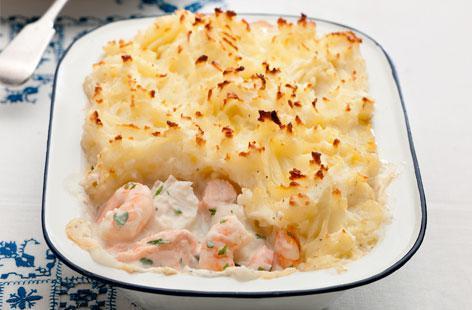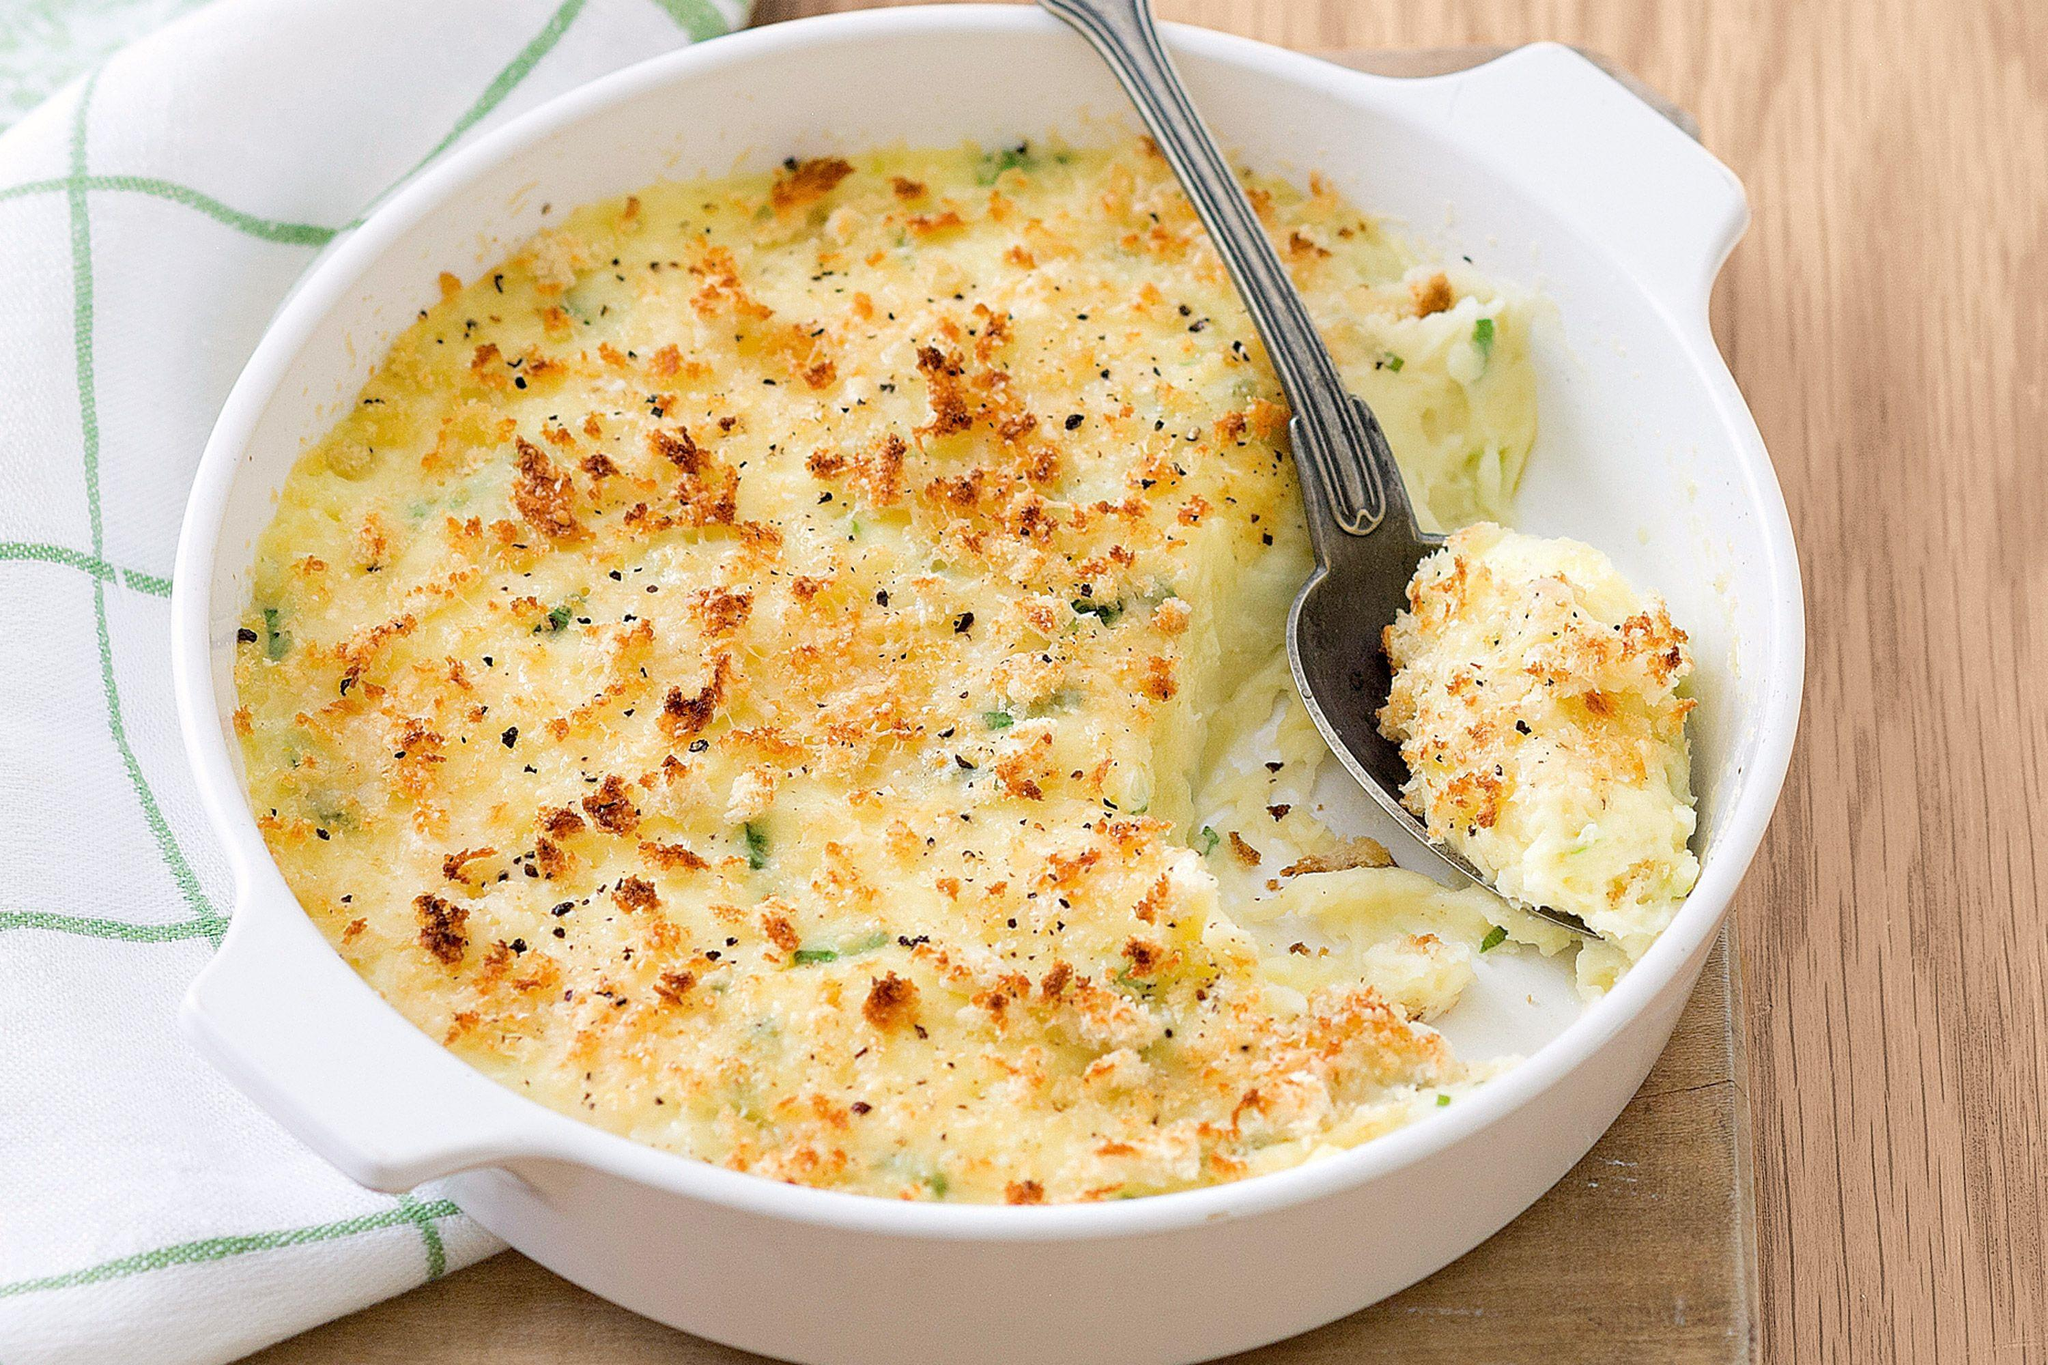The first image is the image on the left, the second image is the image on the right. For the images displayed, is the sentence "There are sppons near mashed potatoes." factually correct? Answer yes or no. Yes. 